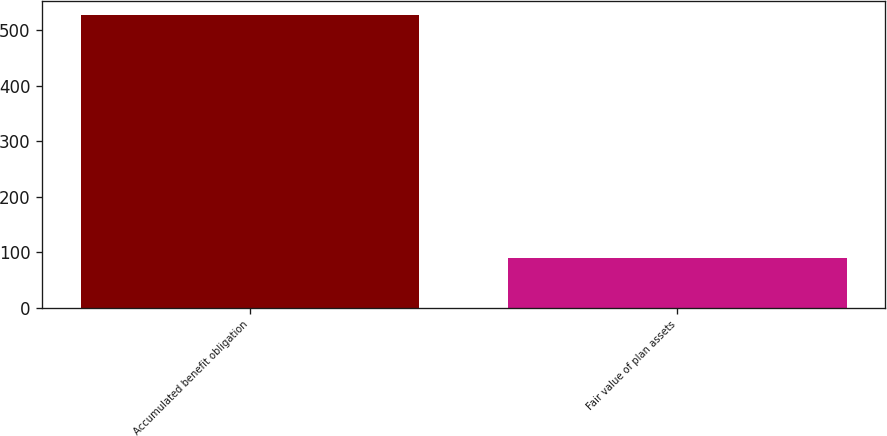<chart> <loc_0><loc_0><loc_500><loc_500><bar_chart><fcel>Accumulated benefit obligation<fcel>Fair value of plan assets<nl><fcel>527<fcel>90<nl></chart> 